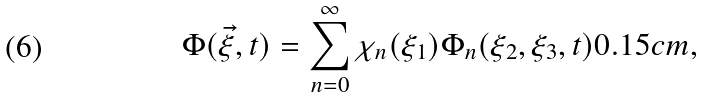Convert formula to latex. <formula><loc_0><loc_0><loc_500><loc_500>\Phi ( \vec { \xi } , t ) = \sum _ { n = 0 } ^ { \infty } \chi _ { n } ( \xi _ { 1 } ) \Phi _ { n } ( \xi _ { 2 } , \xi _ { 3 } , t ) 0 . 1 5 c m ,</formula> 